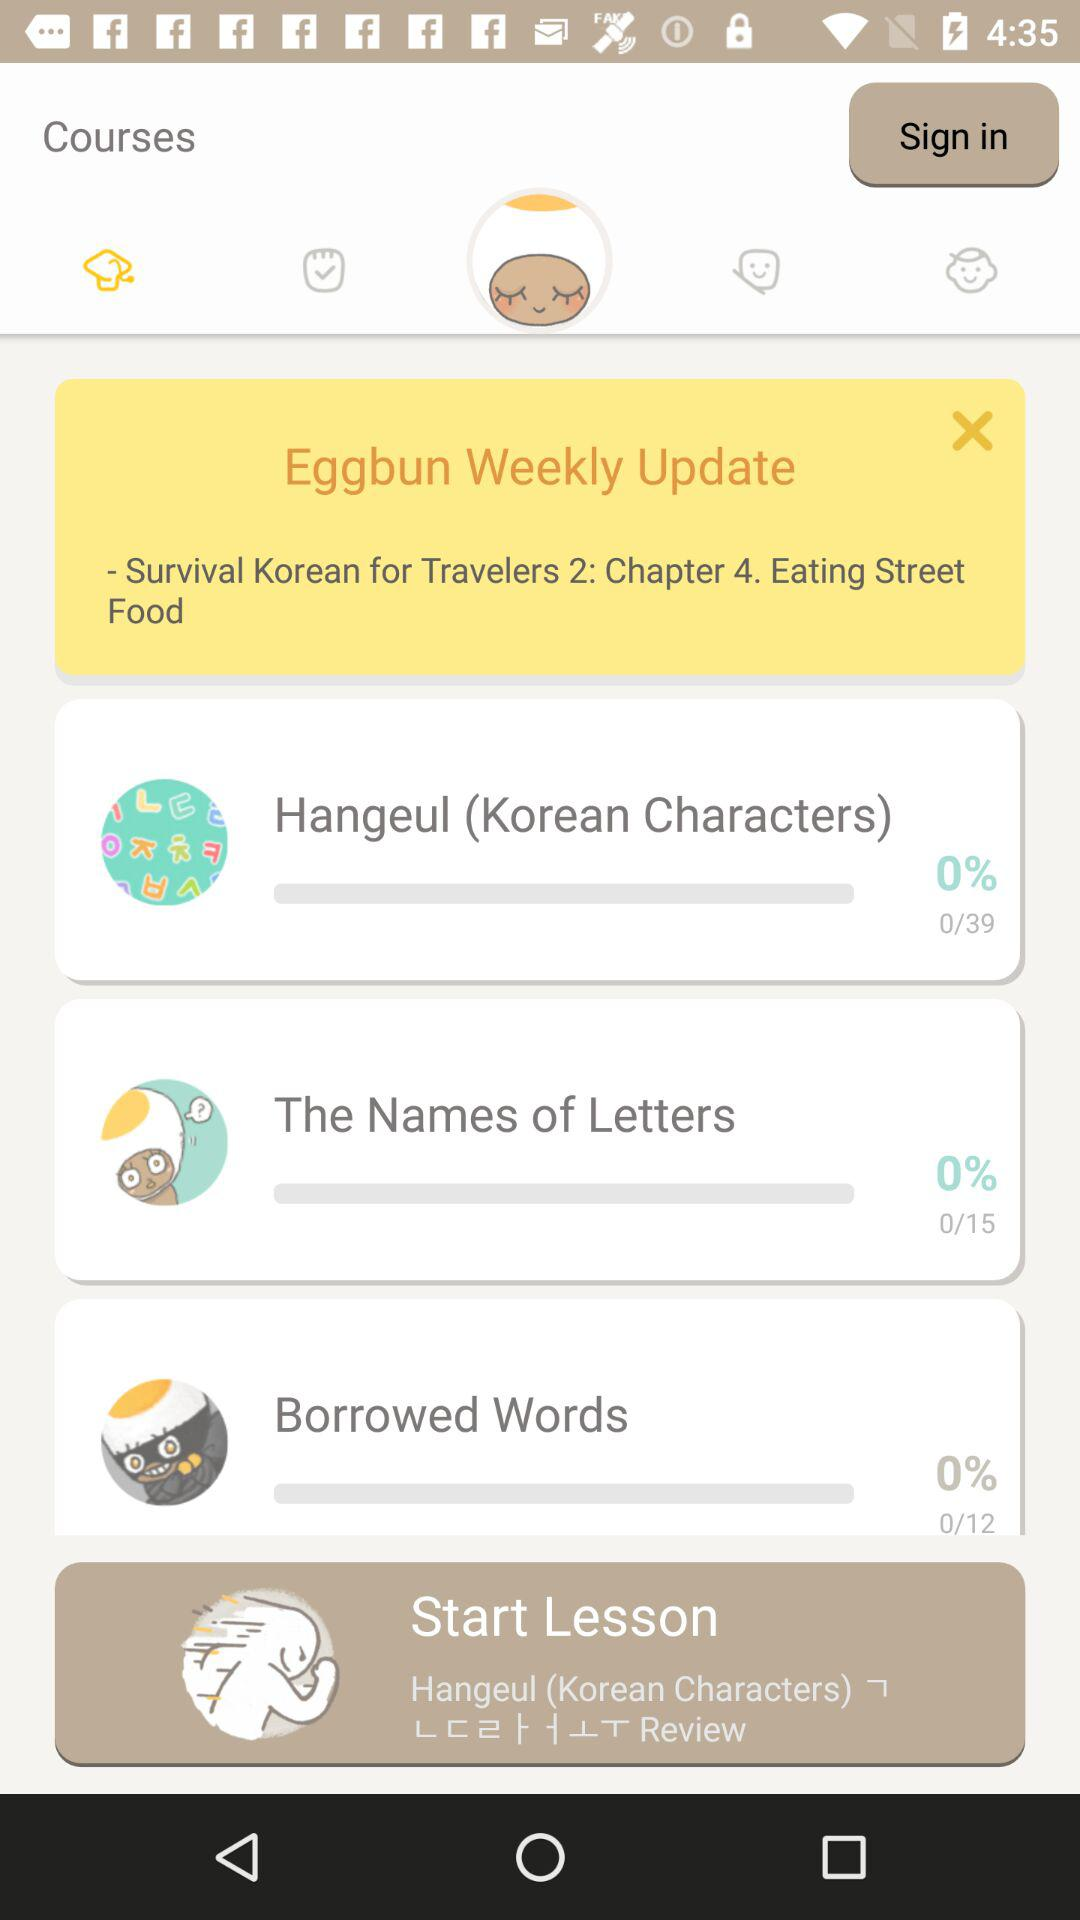How many Hangeul (Korean characters) lessons are there? There are 39 Hangeul (Korean characters) lessons. 